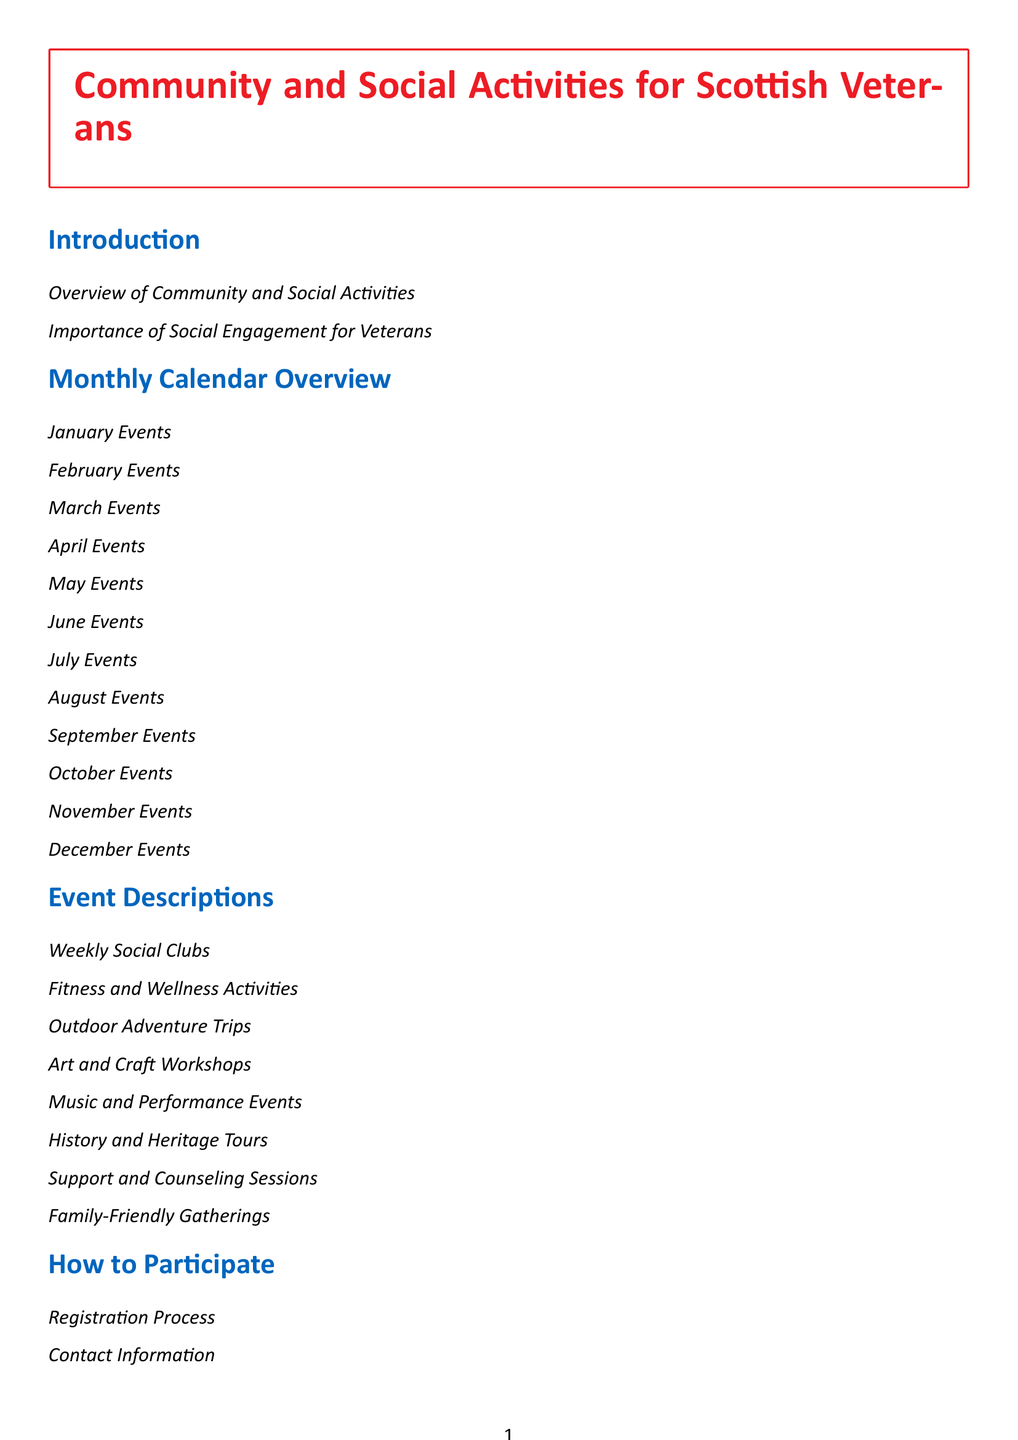What is the title of the document? The title of the document is shown in the table of contents section.
Answer: Community and Social Activities for Scottish Veterans How many months are covered in the Monthly Calendar Overview? The Monthly Calendar Overview includes sections for each month, which totals to twelve.
Answer: 12 What type of activities are included in the Event Descriptions section? The Event Descriptions section includes various activities aimed at veterans.
Answer: Weekly Social Clubs What is one way veterans can get involved according to the How to Participate section? The How to Participate section provides guidance on how veterans can engage with the activities.
Answer: Registration Process Which section contains personal stories from fellow veterans? The section that contains personal stories is outlined in the document structure.
Answer: Testimonials What organization is mentioned as the primary supporter in the Sponsors and Partners section? The primary supporter for veterans mentioned in the document is listed under sponsors.
Answer: Poppyscotland Which category includes outdoor activities? The category that includes outdoor activities provides options for veterans to engage with nature.
Answer: Outdoor Adventure Trips What is the focus of the Additional Resources section? The Additional Resources section aims to provide further support and information for veterans.
Answer: Helpful Links 